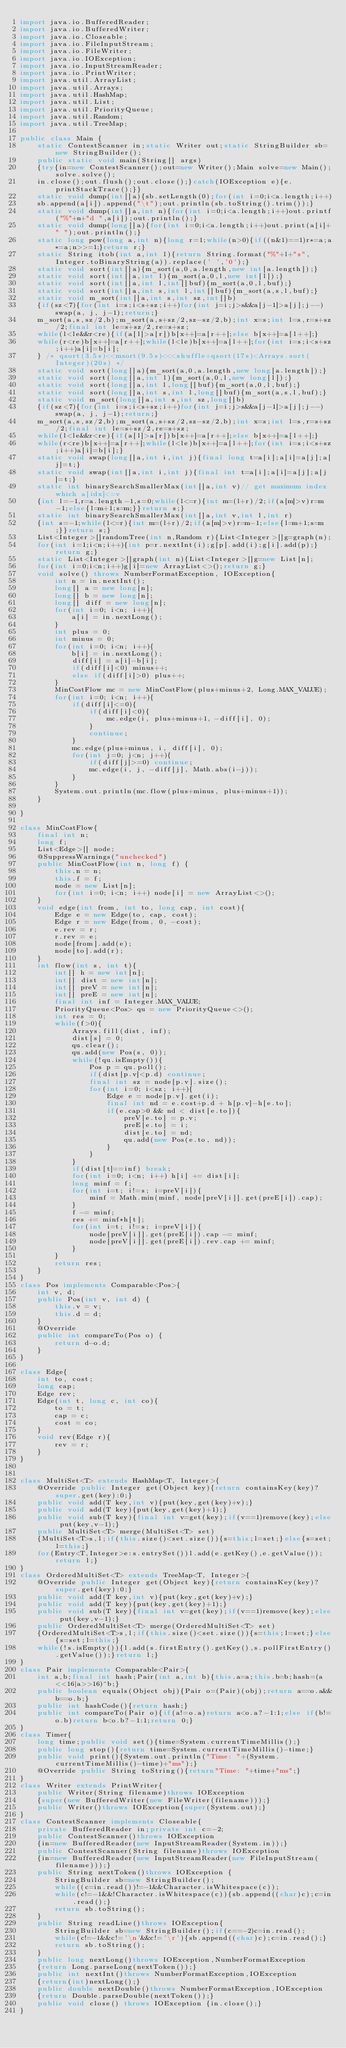<code> <loc_0><loc_0><loc_500><loc_500><_Java_>import java.io.BufferedReader;
import java.io.BufferedWriter;
import java.io.Closeable;
import java.io.FileInputStream;
import java.io.FileWriter;
import java.io.IOException;
import java.io.InputStreamReader;
import java.io.PrintWriter;
import java.util.ArrayList;
import java.util.Arrays;
import java.util.HashMap;
import java.util.List;
import java.util.PriorityQueue;
import java.util.Random;
import java.util.TreeMap;

public class Main {
	static ContestScanner in;static Writer out;static StringBuilder sb=new StringBuilder();
	public static void main(String[] args)
	{try{in=new ContestScanner();out=new Writer();Main solve=new Main();solve.solve();
	in.close();out.flush();out.close();}catch(IOException e){e.printStackTrace();}}
	static void dump(int[]a){sb.setLength(0);for(int i=0;i<a.length;i++)
	sb.append(a[i]).append("\t");out.println(sb.toString().trim());}
	static void dump(int[]a,int n){for(int i=0;i<a.length;i++)out.printf("%"+n+"d ",a[i]);out.println();}
	static void dump(long[]a){for(int i=0;i<a.length;i++)out.print(a[i]+" ");out.println();}
	static long pow(long a,int n){long r=1;while(n>0){if((n&1)==1)r*=a;a*=a;n>>=1;}return r;}
	static String itob(int a,int l){return String.format("%"+l+"s",Integer.toBinaryString(a)).replace(' ','0');}
	static void sort(int[]a){m_sort(a,0,a.length,new int[a.length]);}
	static void sort(int[]a,int l){m_sort(a,0,l,new int[l]);}
	static void sort(int[]a,int l,int[]buf){m_sort(a,0,l,buf);}
	static void sort(int[]a,int s,int l,int[]buf){m_sort(a,s,l,buf);}
	static void m_sort(int[]a,int s,int sz,int[]b)
	{if(sz<7){for(int i=s;i<s+sz;i++)for(int j=i;j>s&&a[j-1]>a[j];j--)swap(a, j, j-1);return;}
	m_sort(a,s,sz/2,b);m_sort(a,s+sz/2,sz-sz/2,b);int x=s;int l=s,r=s+sz/2;final int le=s+sz/2,re=s+sz;
	while(l<le&&r<re){if(a[l]>a[r])b[x++]=a[r++];else b[x++]=a[l++];}
	while(r<re)b[x++]=a[r++];while(l<le)b[x++]=a[l++];for(int i=s;i<s+sz;i++)a[i]=b[i];
	} /* qsort(3.5s)<<msort(9.5s)<<<shuffle+qsort(17s)<Arrays.sort(Integer)(20s) */
	static void sort(long[]a){m_sort(a,0,a.length,new long[a.length]);}
	static void sort(long[]a,int l){m_sort(a,0,l,new long[l]);}
	static void sort(long[]a,int l,long[]buf){m_sort(a,0,l,buf);}
	static void sort(long[]a,int s,int l,long[]buf){m_sort(a,s,l,buf);}
	static void m_sort(long[]a,int s,int sz,long[]b)
	{if(sz<7){for(int i=s;i<s+sz;i++)for(int j=i;j>s&&a[j-1]>a[j];j--)swap(a, j, j-1);return;}
	m_sort(a,s,sz/2,b);m_sort(a,s+sz/2,sz-sz/2,b);int x=s;int l=s,r=s+sz/2;final int le=s+sz/2,re=s+sz;
	while(l<le&&r<re){if(a[l]>a[r])b[x++]=a[r++];else b[x++]=a[l++];}
	while(r<re)b[x++]=a[r++];while(l<le)b[x++]=a[l++];for(int i=s;i<s+sz;i++)a[i]=b[i];}
	static void swap(long[]a,int i,int j){final long t=a[i];a[i]=a[j];a[j]=t;}
	static void swap(int[]a,int i,int j){final int t=a[i];a[i]=a[j];a[j]=t;}
	static int binarySearchSmallerMax(int[]a,int v)// get maximum index which a[idx]<=v
	{int l=-1,r=a.length-1,s=0;while(l<=r){int m=(l+r)/2;if(a[m]>v)r=m-1;else{l=m+1;s=m;}}return s;}
	static int binarySearchSmallerMax(int[]a,int v,int l,int r)
	{int s=-1;while(l<=r){int m=(l+r)/2;if(a[m]>v)r=m-1;else{l=m+1;s=m;}}return s;}
	List<Integer>[]randomTree(int n,Random r){List<Integer>[]g=graph(n);
	for(int i=1;i<n;i++){int p=r.nextInt(i);g[p].add(i);g[i].add(p);}return g;}
	static List<Integer>[]graph(int n){List<Integer>[]g=new List[n];
	for(int i=0;i<n;i++)g[i]=new ArrayList<>();return g;}
	void solve() throws NumberFormatException, IOException{
		int n = in.nextInt();
		long[] a = new long[n];
		long[] b = new long[n];
		long[] diff = new long[n];
		for(int i=0; i<n; i++){
			a[i] = in.nextLong();
		}
		int plus = 0;
		int minus = 0;
		for(int i=0; i<n; i++){
			b[i] = in.nextLong();
			diff[i] = a[i]-b[i];
			if(diff[i]<0) minus++;
			else if(diff[i]>0) plus++;
		}
		MinCostFlow mc = new MinCostFlow(plus+minus+2, Long.MAX_VALUE);
		for(int i=0; i<n; i++){
			if(diff[i]<=0){
				if(diff[i]<0){
					mc.edge(i, plus+minus+1, -diff[i], 0);
				}
				continue;
			}
			mc.edge(plus+minus, i, diff[i], 0);
			for(int j=0; j<n; j++){
				if(diff[j]>=0) continue;
				mc.edge(i, j, -diff[j], Math.abs(i-j));
			}
		}
		System.out.println(mc.flow(plus+minus, plus+minus+1));
	}
	
}

class MinCostFlow{
	final int n;
	long f;
	List<Edge>[] node;
	@SuppressWarnings("unchecked")
	public MinCostFlow(int n, long f) {
		this.n = n;
		this.f = f;
		node = new List[n];
		for(int i=0; i<n; i++) node[i] = new ArrayList<>();
	}
	void edge(int from, int to, long cap, int cost){
		Edge e = new Edge(to, cap, cost);
		Edge r = new Edge(from, 0, -cost);
		e.rev = r;
		r.rev = e;
		node[from].add(e);
		node[to].add(r);
	}
	int flow(int s, int t){
		int[] h = new int[n];
		int[] dist = new int[n];
		int[] preV = new int[n];
		int[] preE = new int[n];
		final int inf = Integer.MAX_VALUE;
		PriorityQueue<Pos> qu = new PriorityQueue<>();
		int res = 0;
		while(f>0){
			Arrays.fill(dist, inf);
			dist[s] = 0;
			qu.clear();
			qu.add(new Pos(s, 0));
			while(!qu.isEmpty()){
				Pos p = qu.poll();
				if(dist[p.v]<p.d) continue;
				final int sz = node[p.v].size();
				for(int i=0; i<sz; i++){
					Edge e = node[p.v].get(i);
					final int nd = e.cost+p.d + h[p.v]-h[e.to];
					if(e.cap>0 && nd < dist[e.to]){
						preV[e.to] = p.v;
						preE[e.to] = i;
						dist[e.to] = nd;
						qu.add(new Pos(e.to, nd));
					}
				}
			}
			if(dist[t]==inf) break;
			for(int i=0; i<n; i++) h[i] += dist[i];
			long minf = f;
			for(int i=t; i!=s; i=preV[i]){
				minf = Math.min(minf, node[preV[i]].get(preE[i]).cap);
			}
			f -= minf;
			res += minf*h[t];
			for(int i=t; i!=s; i=preV[i]){
				node[preV[i]].get(preE[i]).cap -= minf;
				node[preV[i]].get(preE[i]).rev.cap += minf;
			}
		}
		return res;
	}
}
class Pos implements Comparable<Pos>{
	int v, d;
	public Pos(int v, int d) {
		this.v = v;
		this.d = d;
	}
	@Override
	public int compareTo(Pos o) {
		return d-o.d;
	}
}

class Edge{
	int to, cost;
	long cap;
	Edge rev;
	Edge(int t, long c, int co){
		to = t;
		cap = c;
		cost = co;
	}
	void rev(Edge r){
		rev = r;
	}
}


class MultiSet<T> extends HashMap<T, Integer>{
	@Override public Integer get(Object key){return containsKey(key)?super.get(key):0;}
	public void add(T key,int v){put(key,get(key)+v);}
	public void add(T key){put(key,get(key)+1);}
	public void sub(T key){final int v=get(key);if(v==1)remove(key);else put(key,v-1);}
	public MultiSet<T> merge(MultiSet<T> set)
	{MultiSet<T>s,l;if(this.size()<set.size()){s=this;l=set;}else{s=set;l=this;}
	for(Entry<T,Integer>e:s.entrySet())l.add(e.getKey(),e.getValue());return l;}
}
class OrderedMultiSet<T> extends TreeMap<T, Integer>{
	@Override public Integer get(Object key){return containsKey(key)?super.get(key):0;}
	public void add(T key,int v){put(key,get(key)+v);}
	public void add(T key){put(key,get(key)+1);}
	public void sub(T key){final int v=get(key);if(v==1)remove(key);else put(key,v-1);}
	public OrderedMultiSet<T> merge(OrderedMultiSet<T> set)
	{OrderedMultiSet<T>s,l;if(this.size()<set.size()){s=this;l=set;}else{s=set;l=this;}
	while(!s.isEmpty()){l.add(s.firstEntry().getKey(),s.pollFirstEntry().getValue());}return l;}
}
class Pair implements Comparable<Pair>{
	int a,b;final int hash;Pair(int a,int b){this.a=a;this.b=b;hash=(a<<16|a>>16)^b;}
	public boolean equals(Object obj){Pair o=(Pair)(obj);return a==o.a&&b==o.b;}
	public int hashCode(){return hash;}
	public int compareTo(Pair o){if(a!=o.a)return a<o.a?-1:1;else if(b!=o.b)return b<o.b?-1:1;return 0;}
}
class Timer{
	long time;public void set(){time=System.currentTimeMillis();}
	public long stop(){return time=System.currentTimeMillis()-time;}
	public void print(){System.out.println("Time: "+(System.currentTimeMillis()-time)+"ms");}
	@Override public String toString(){return"Time: "+time+"ms";}
}
class Writer extends PrintWriter{
	public Writer(String filename)throws IOException
	{super(new BufferedWriter(new FileWriter(filename)));}
	public Writer()throws IOException{super(System.out);}
}
class ContestScanner implements Closeable{
	private BufferedReader in;private int c=-2;
	public ContestScanner()throws IOException 
	{in=new BufferedReader(new InputStreamReader(System.in));}
	public ContestScanner(String filename)throws IOException
	{in=new BufferedReader(new InputStreamReader(new FileInputStream(filename)));}
	public String nextToken()throws IOException {
		StringBuilder sb=new StringBuilder();
		while((c=in.read())!=-1&&Character.isWhitespace(c));
		while(c!=-1&&!Character.isWhitespace(c)){sb.append((char)c);c=in.read();}
		return sb.toString();
	}
	public String readLine()throws IOException{
		StringBuilder sb=new StringBuilder();if(c==-2)c=in.read();
		while(c!=-1&&c!='\n'&&c!='\r'){sb.append((char)c);c=in.read();}
		return sb.toString();
	}
	public long nextLong()throws IOException,NumberFormatException
	{return Long.parseLong(nextToken());}
	public int nextInt()throws NumberFormatException,IOException
	{return(int)nextLong();}
	public double nextDouble()throws NumberFormatException,IOException 
	{return Double.parseDouble(nextToken());}
	public void close() throws IOException {in.close();}
}</code> 